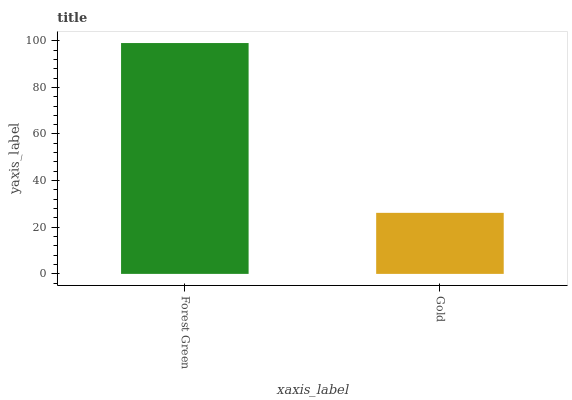Is Gold the minimum?
Answer yes or no. Yes. Is Forest Green the maximum?
Answer yes or no. Yes. Is Gold the maximum?
Answer yes or no. No. Is Forest Green greater than Gold?
Answer yes or no. Yes. Is Gold less than Forest Green?
Answer yes or no. Yes. Is Gold greater than Forest Green?
Answer yes or no. No. Is Forest Green less than Gold?
Answer yes or no. No. Is Forest Green the high median?
Answer yes or no. Yes. Is Gold the low median?
Answer yes or no. Yes. Is Gold the high median?
Answer yes or no. No. Is Forest Green the low median?
Answer yes or no. No. 